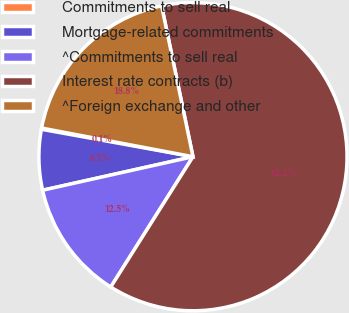Convert chart. <chart><loc_0><loc_0><loc_500><loc_500><pie_chart><fcel>Commitments to sell real<fcel>Mortgage-related commitments<fcel>^Commitments to sell real<fcel>Interest rate contracts (b)<fcel>^Foreign exchange and other<nl><fcel>0.13%<fcel>6.34%<fcel>12.55%<fcel>62.22%<fcel>18.76%<nl></chart> 